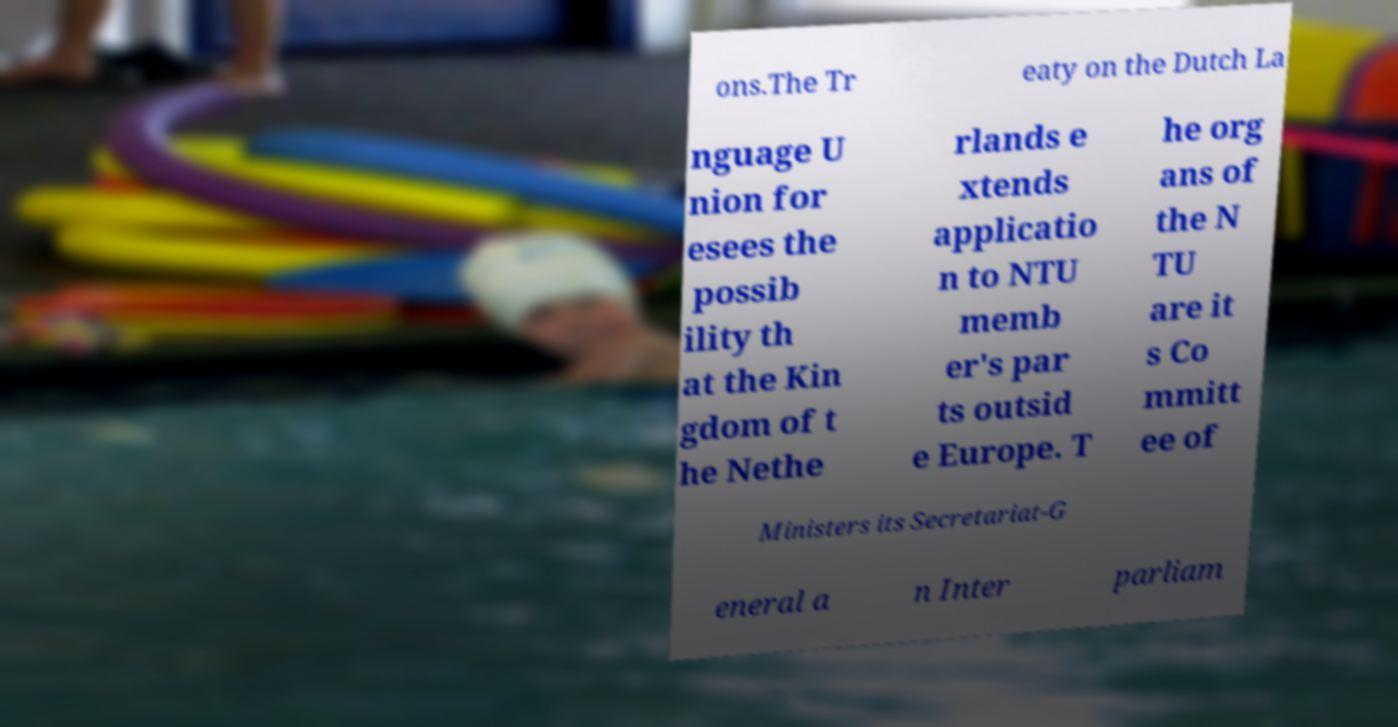Can you accurately transcribe the text from the provided image for me? ons.The Tr eaty on the Dutch La nguage U nion for esees the possib ility th at the Kin gdom of t he Nethe rlands e xtends applicatio n to NTU memb er's par ts outsid e Europe. T he org ans of the N TU are it s Co mmitt ee of Ministers its Secretariat-G eneral a n Inter parliam 